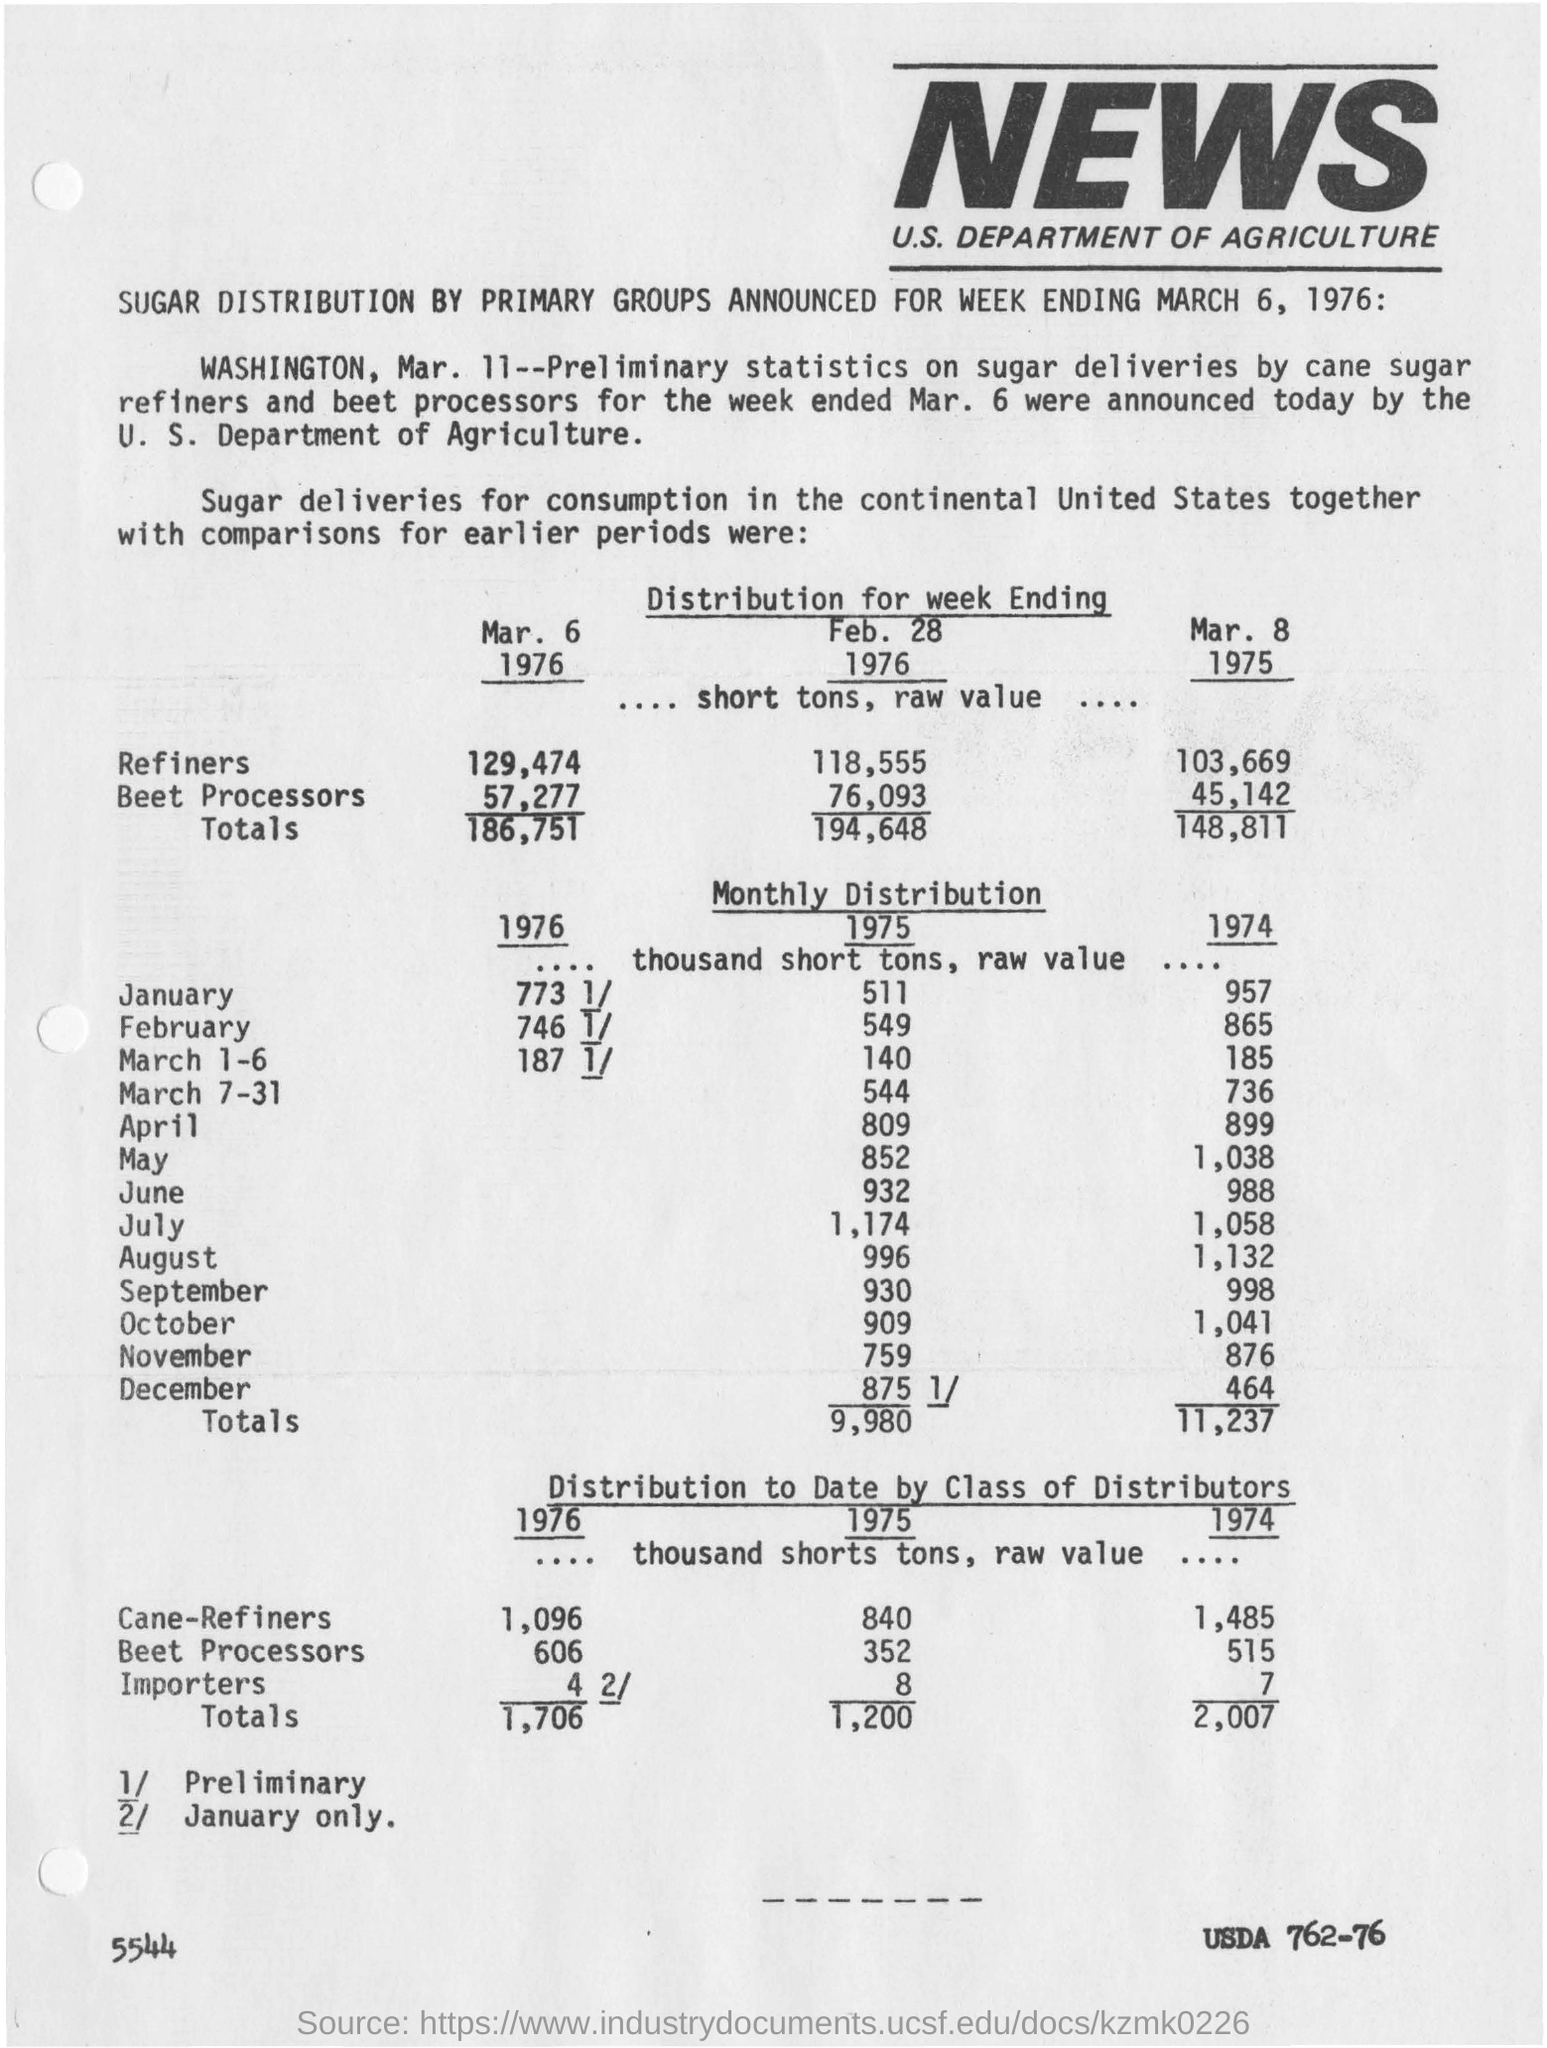Draw attention to some important aspects in this diagram. News coverage is prevalent in the United States. I'm sorry, but I'm not sure what you are asking. Could you please provide more context or clarify your question? The article mentions the distribution of sugar. 